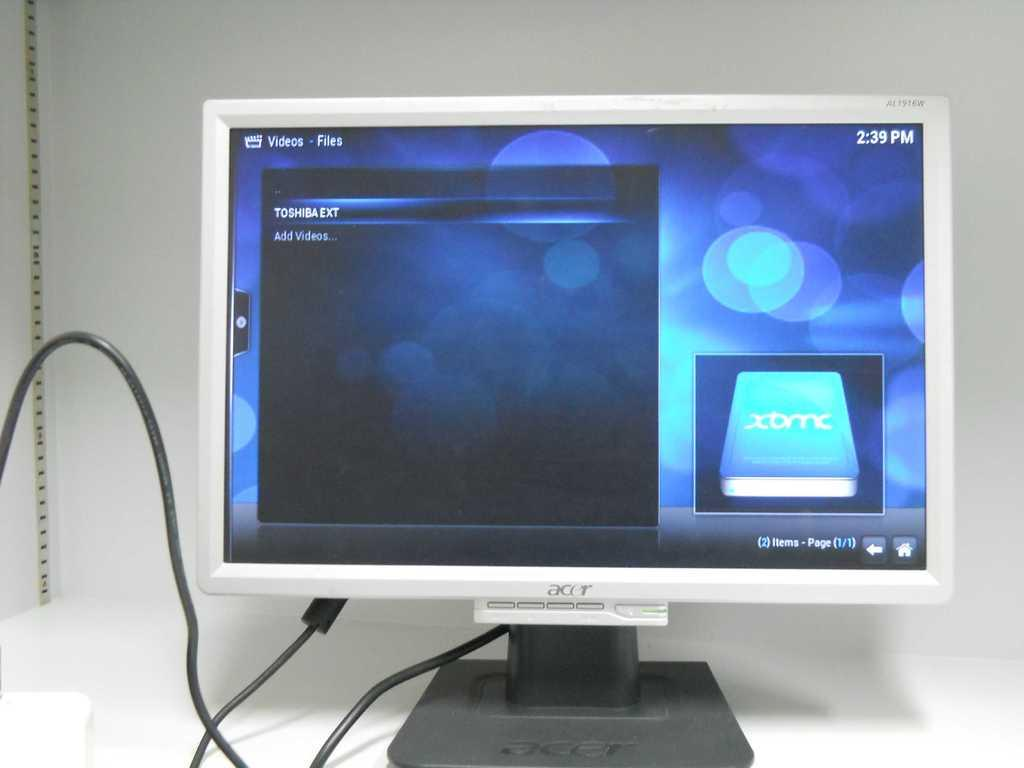<image>
Render a clear and concise summary of the photo. A computer monitor screen displaying a hard disk menu and the time. 